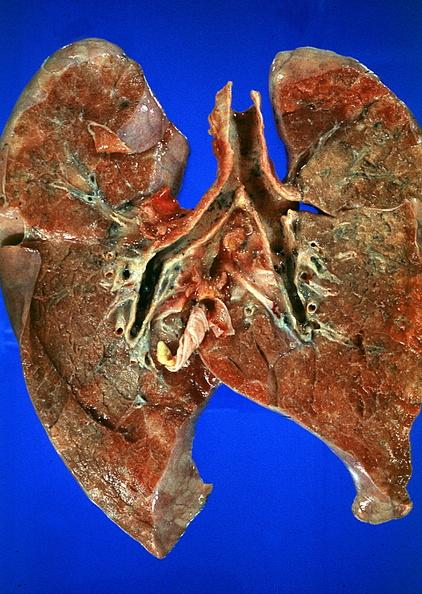where is this?
Answer the question using a single word or phrase. Lung 